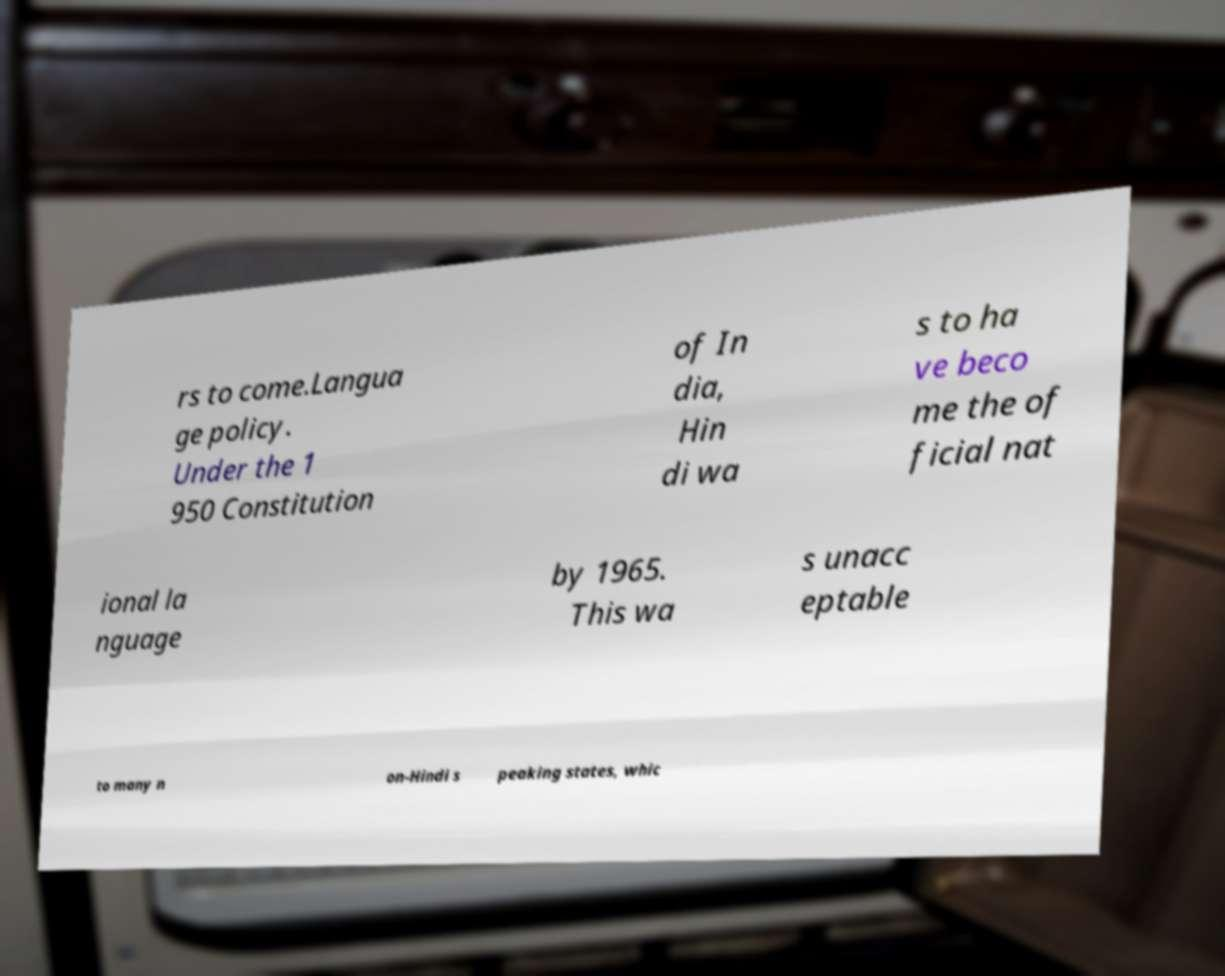Could you extract and type out the text from this image? rs to come.Langua ge policy. Under the 1 950 Constitution of In dia, Hin di wa s to ha ve beco me the of ficial nat ional la nguage by 1965. This wa s unacc eptable to many n on-Hindi s peaking states, whic 